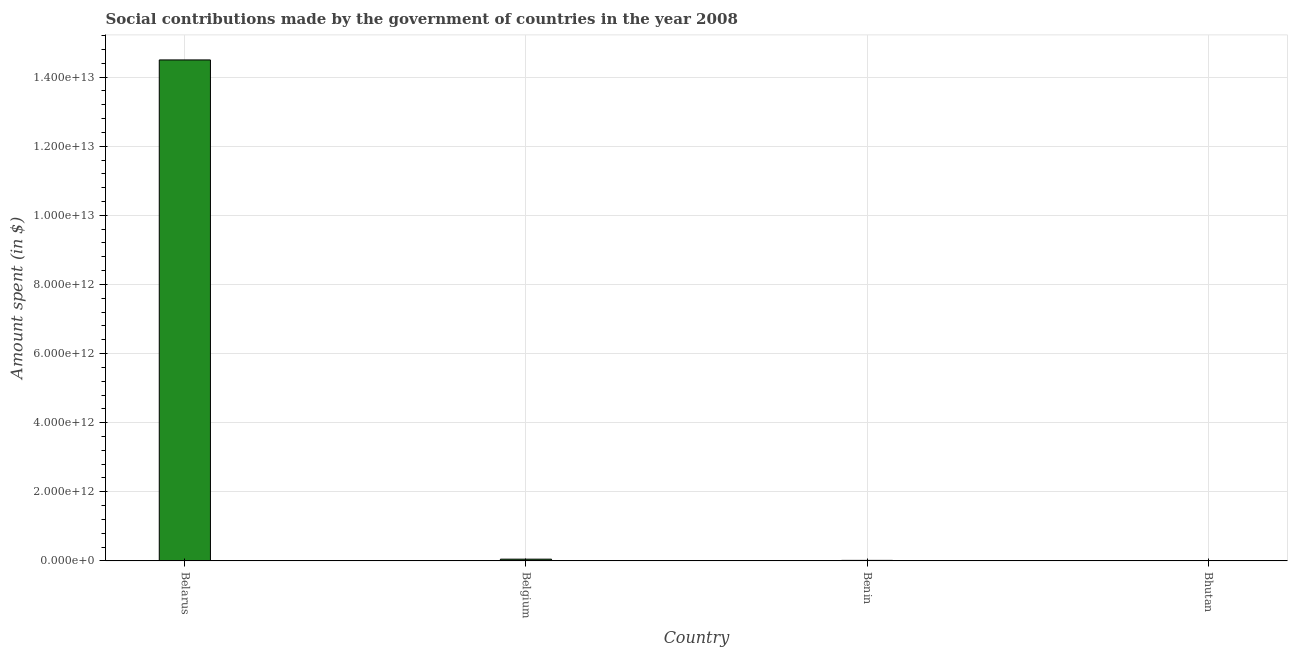Does the graph contain any zero values?
Make the answer very short. No. What is the title of the graph?
Your response must be concise. Social contributions made by the government of countries in the year 2008. What is the label or title of the Y-axis?
Keep it short and to the point. Amount spent (in $). What is the amount spent in making social contributions in Benin?
Provide a short and direct response. 1.48e+1. Across all countries, what is the maximum amount spent in making social contributions?
Give a very brief answer. 1.45e+13. Across all countries, what is the minimum amount spent in making social contributions?
Ensure brevity in your answer.  5.82e+07. In which country was the amount spent in making social contributions maximum?
Give a very brief answer. Belarus. In which country was the amount spent in making social contributions minimum?
Keep it short and to the point. Bhutan. What is the sum of the amount spent in making social contributions?
Offer a terse response. 1.46e+13. What is the difference between the amount spent in making social contributions in Benin and Bhutan?
Offer a very short reply. 1.47e+1. What is the average amount spent in making social contributions per country?
Offer a terse response. 3.64e+12. What is the median amount spent in making social contributions?
Your answer should be compact. 3.24e+1. What is the ratio of the amount spent in making social contributions in Belarus to that in Belgium?
Provide a short and direct response. 289.99. Is the difference between the amount spent in making social contributions in Belarus and Belgium greater than the difference between any two countries?
Provide a short and direct response. No. What is the difference between the highest and the second highest amount spent in making social contributions?
Offer a very short reply. 1.44e+13. What is the difference between the highest and the lowest amount spent in making social contributions?
Make the answer very short. 1.45e+13. How many countries are there in the graph?
Your answer should be very brief. 4. What is the difference between two consecutive major ticks on the Y-axis?
Your answer should be compact. 2.00e+12. What is the Amount spent (in $) in Belarus?
Keep it short and to the point. 1.45e+13. What is the Amount spent (in $) in Belgium?
Your response must be concise. 5.00e+1. What is the Amount spent (in $) of Benin?
Offer a terse response. 1.48e+1. What is the Amount spent (in $) in Bhutan?
Give a very brief answer. 5.82e+07. What is the difference between the Amount spent (in $) in Belarus and Belgium?
Keep it short and to the point. 1.44e+13. What is the difference between the Amount spent (in $) in Belarus and Benin?
Keep it short and to the point. 1.45e+13. What is the difference between the Amount spent (in $) in Belarus and Bhutan?
Your answer should be compact. 1.45e+13. What is the difference between the Amount spent (in $) in Belgium and Benin?
Give a very brief answer. 3.52e+1. What is the difference between the Amount spent (in $) in Belgium and Bhutan?
Offer a terse response. 4.99e+1. What is the difference between the Amount spent (in $) in Benin and Bhutan?
Keep it short and to the point. 1.47e+1. What is the ratio of the Amount spent (in $) in Belarus to that in Belgium?
Offer a very short reply. 289.99. What is the ratio of the Amount spent (in $) in Belarus to that in Benin?
Provide a succinct answer. 980.6. What is the ratio of the Amount spent (in $) in Belarus to that in Bhutan?
Your answer should be compact. 2.49e+05. What is the ratio of the Amount spent (in $) in Belgium to that in Benin?
Offer a very short reply. 3.38. What is the ratio of the Amount spent (in $) in Belgium to that in Bhutan?
Offer a terse response. 859.01. What is the ratio of the Amount spent (in $) in Benin to that in Bhutan?
Ensure brevity in your answer.  254.03. 